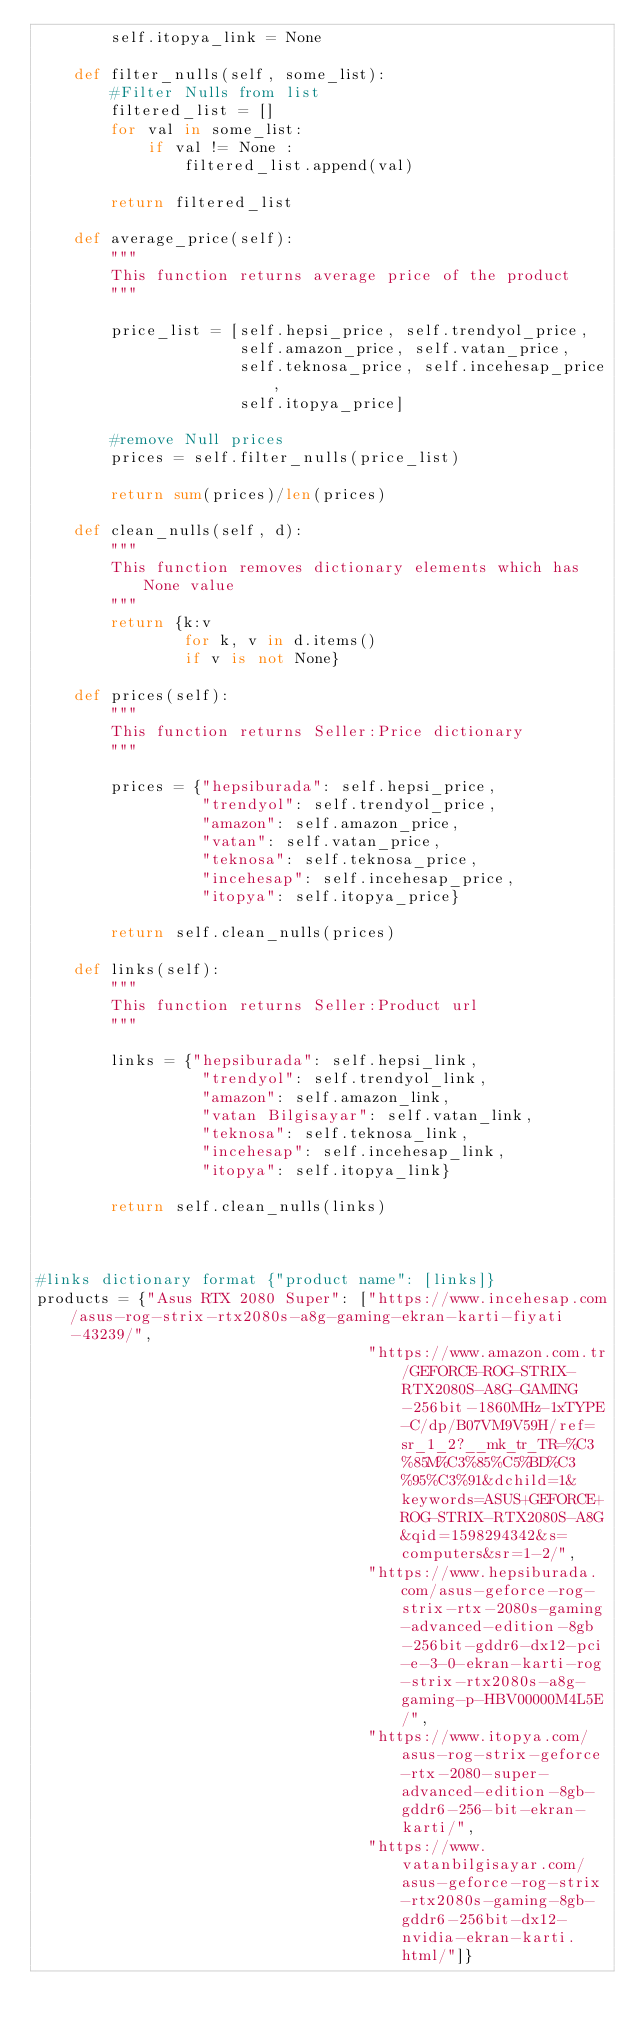Convert code to text. <code><loc_0><loc_0><loc_500><loc_500><_Python_>        self.itopya_link = None
    
    def filter_nulls(self, some_list):
        #Filter Nulls from list
        filtered_list = [] 
        for val in some_list: 
            if val != None : 
                filtered_list.append(val) 

        return filtered_list

    def average_price(self):
        """
        This function returns average price of the product
        """

        price_list = [self.hepsi_price, self.trendyol_price,
                      self.amazon_price, self.vatan_price,
                      self.teknosa_price, self.incehesap_price,
                      self.itopya_price]

        #remove Null prices
        prices = self.filter_nulls(price_list)
        
        return sum(prices)/len(prices)

    def clean_nulls(self, d):
        """
        This function removes dictionary elements which has None value
        """
        return {k:v 
                for k, v in d.items() 
                if v is not None}

    def prices(self):
        """
        This function returns Seller:Price dictionary
        """

        prices = {"hepsiburada": self.hepsi_price,
                  "trendyol": self.trendyol_price,
                  "amazon": self.amazon_price,
                  "vatan": self.vatan_price,
                  "teknosa": self.teknosa_price,
                  "incehesap": self.incehesap_price,
                  "itopya": self.itopya_price}
        
        return self.clean_nulls(prices)

    def links(self):
        """
        This function returns Seller:Product url
        """

        links = {"hepsiburada": self.hepsi_link,
                  "trendyol": self.trendyol_link,
                  "amazon": self.amazon_link,
                  "vatan Bilgisayar": self.vatan_link,
                  "teknosa": self.teknosa_link,
                  "incehesap": self.incehesap_link,
                  "itopya": self.itopya_link}
        
        return self.clean_nulls(links)



#links dictionary format {"product name": [links]}
products = {"Asus RTX 2080 Super": ["https://www.incehesap.com/asus-rog-strix-rtx2080s-a8g-gaming-ekran-karti-fiyati-43239/",
                                    "https://www.amazon.com.tr/GEFORCE-ROG-STRIX-RTX2080S-A8G-GAMING-256bit-1860MHz-1xTYPE-C/dp/B07VM9V59H/ref=sr_1_2?__mk_tr_TR=%C3%85M%C3%85%C5%BD%C3%95%C3%91&dchild=1&keywords=ASUS+GEFORCE+ROG-STRIX-RTX2080S-A8G&qid=1598294342&s=computers&sr=1-2/",
                                    "https://www.hepsiburada.com/asus-geforce-rog-strix-rtx-2080s-gaming-advanced-edition-8gb-256bit-gddr6-dx12-pci-e-3-0-ekran-karti-rog-strix-rtx2080s-a8g-gaming-p-HBV00000M4L5E/",
                                    "https://www.itopya.com/asus-rog-strix-geforce-rtx-2080-super-advanced-edition-8gb-gddr6-256-bit-ekran-karti/",
                                    "https://www.vatanbilgisayar.com/asus-geforce-rog-strix-rtx2080s-gaming-8gb-gddr6-256bit-dx12-nvidia-ekran-karti.html/"]}




</code> 